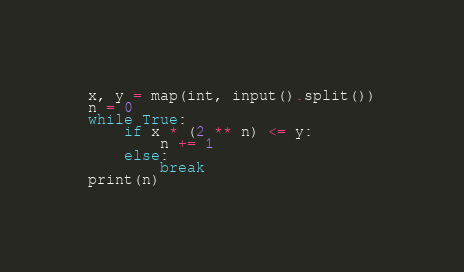Convert code to text. <code><loc_0><loc_0><loc_500><loc_500><_Python_>x, y = map(int, input().split())
n = 0
while True:
    if x * (2 ** n) <= y:
        n += 1
    else:
        break
print(n)</code> 